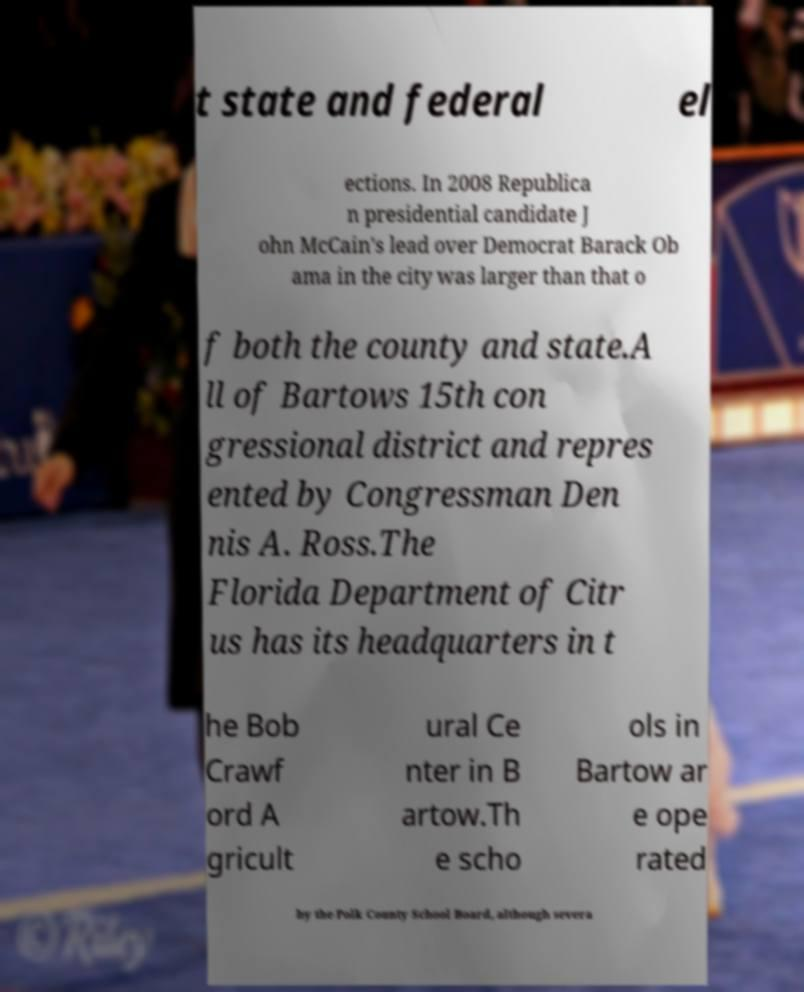Could you extract and type out the text from this image? t state and federal el ections. In 2008 Republica n presidential candidate J ohn McCain's lead over Democrat Barack Ob ama in the city was larger than that o f both the county and state.A ll of Bartows 15th con gressional district and repres ented by Congressman Den nis A. Ross.The Florida Department of Citr us has its headquarters in t he Bob Crawf ord A gricult ural Ce nter in B artow.Th e scho ols in Bartow ar e ope rated by the Polk County School Board, although severa 